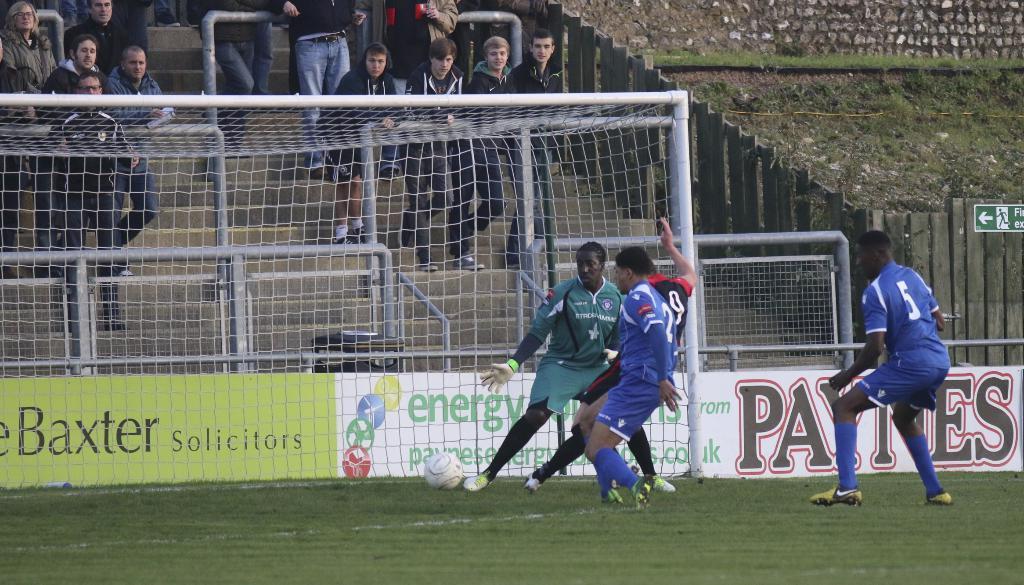Please provide a concise description of this image. In this image I can see some people are playing the football. In the background, I can see some people are standing. I can see the grass. 